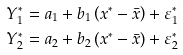Convert formula to latex. <formula><loc_0><loc_0><loc_500><loc_500>Y _ { 1 } ^ { * } = a _ { 1 } + b _ { 1 } \left ( x ^ { * } - \bar { x } \right ) + \varepsilon _ { 1 } ^ { * } \\ Y _ { 2 } ^ { * } = a _ { 2 } + b _ { 2 } \left ( x ^ { * } - \bar { x } \right ) + \varepsilon _ { 2 } ^ { * }</formula> 